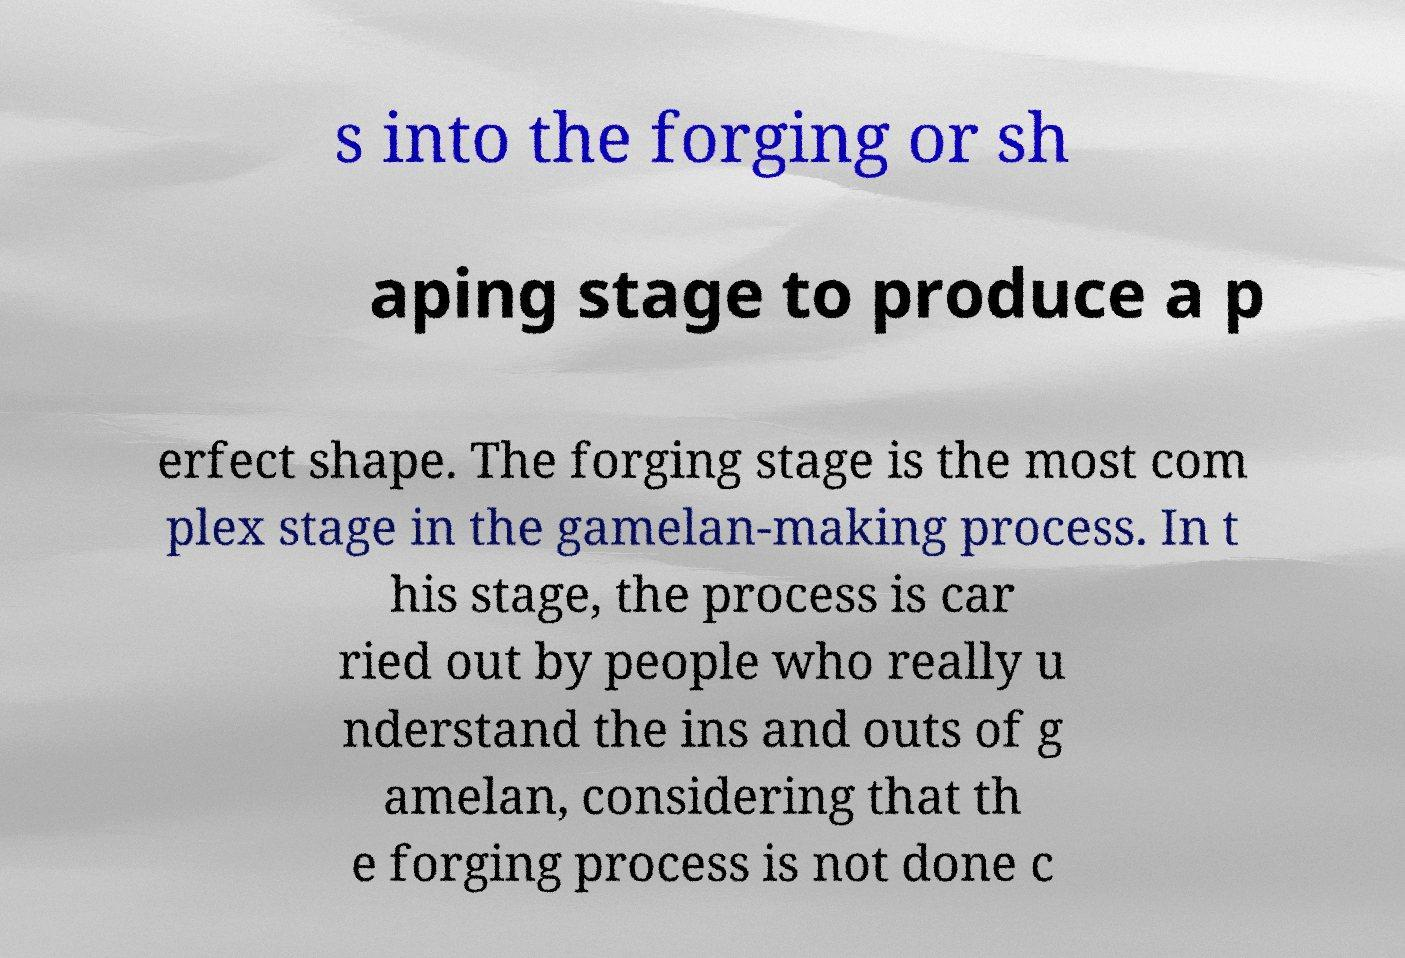Can you read and provide the text displayed in the image?This photo seems to have some interesting text. Can you extract and type it out for me? s into the forging or sh aping stage to produce a p erfect shape. The forging stage is the most com plex stage in the gamelan-making process. In t his stage, the process is car ried out by people who really u nderstand the ins and outs of g amelan, considering that th e forging process is not done c 